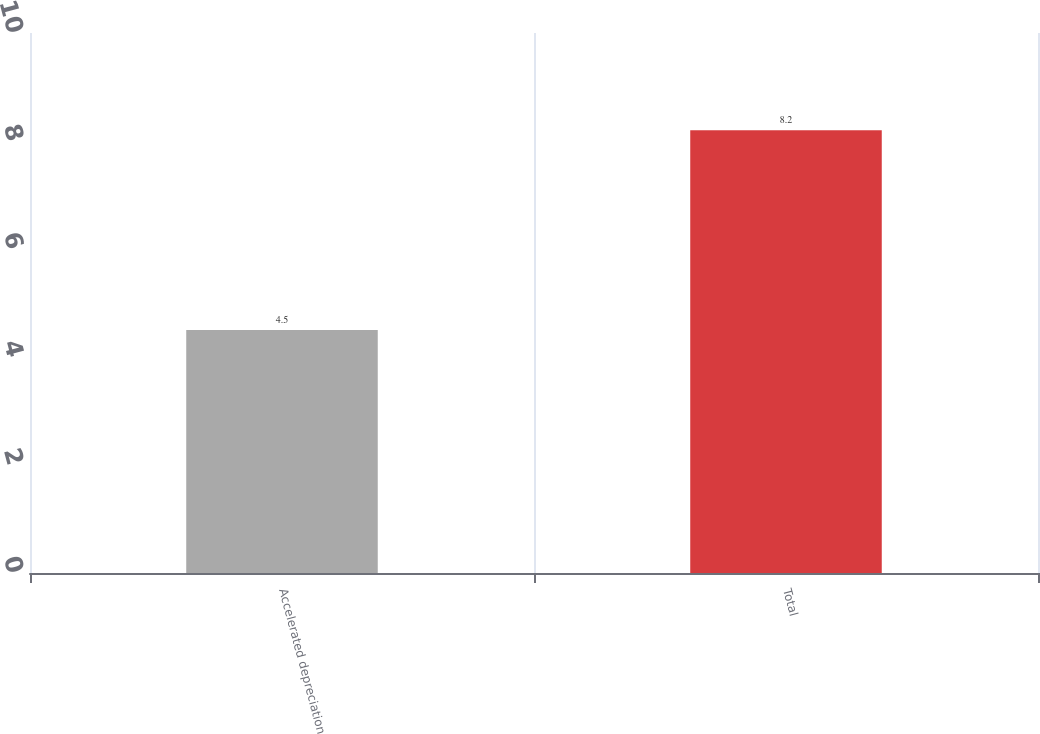Convert chart. <chart><loc_0><loc_0><loc_500><loc_500><bar_chart><fcel>Accelerated depreciation<fcel>Total<nl><fcel>4.5<fcel>8.2<nl></chart> 